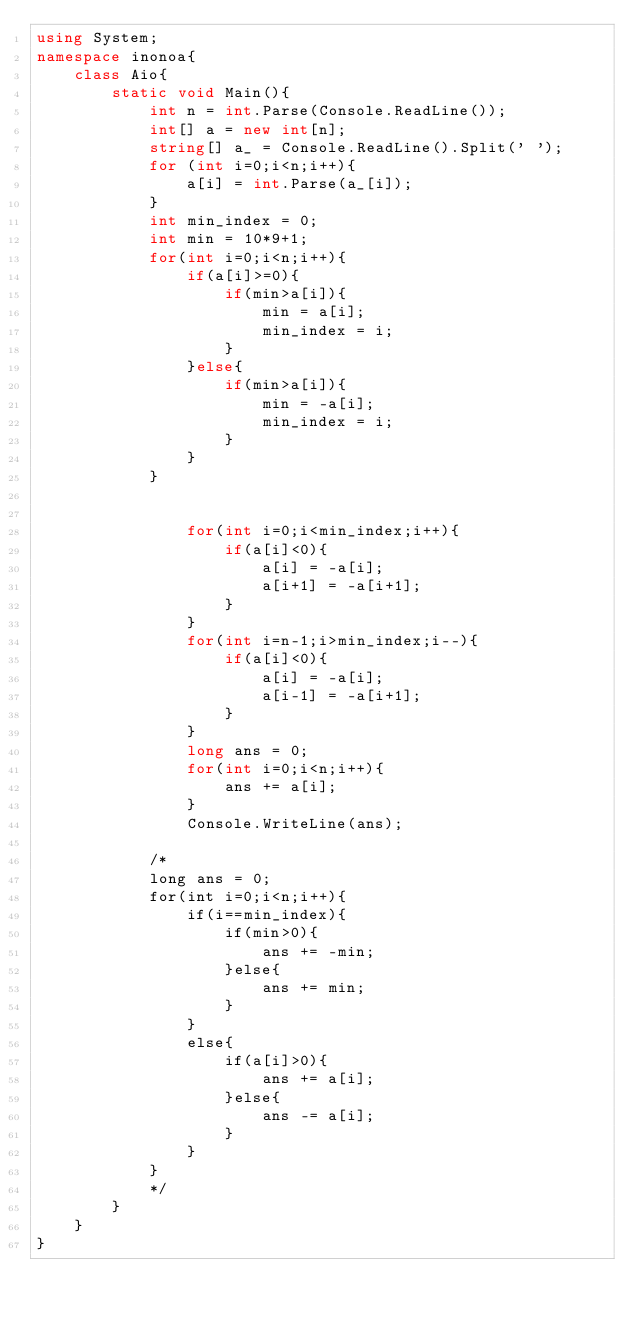<code> <loc_0><loc_0><loc_500><loc_500><_C#_>using System;
namespace inonoa{
    class Aio{
        static void Main(){
            int n = int.Parse(Console.ReadLine());
            int[] a = new int[n];
            string[] a_ = Console.ReadLine().Split(' ');
            for (int i=0;i<n;i++){
                a[i] = int.Parse(a_[i]);
            }
            int min_index = 0;
            int min = 10*9+1;
            for(int i=0;i<n;i++){
                if(a[i]>=0){
                    if(min>a[i]){
                        min = a[i];
                        min_index = i;
                    }
                }else{
                    if(min>a[i]){
                        min = -a[i];
                        min_index = i;
                    }
                }
            }

            
                for(int i=0;i<min_index;i++){
                    if(a[i]<0){
                        a[i] = -a[i];
                        a[i+1] = -a[i+1];
                    }
                }
                for(int i=n-1;i>min_index;i--){
                    if(a[i]<0){
                        a[i] = -a[i];
                        a[i-1] = -a[i+1];
                    }
                }
                long ans = 0;
                for(int i=0;i<n;i++){
                    ans += a[i];
                }
                Console.WriteLine(ans);

            /* 
            long ans = 0;
            for(int i=0;i<n;i++){
                if(i==min_index){
                    if(min>0){
                        ans += -min;
                    }else{
                        ans += min;
                    }
                }
                else{
                    if(a[i]>0){
                        ans += a[i];
                    }else{
                        ans -= a[i];
                    }
                }
            }
            */
        }
    }
}</code> 